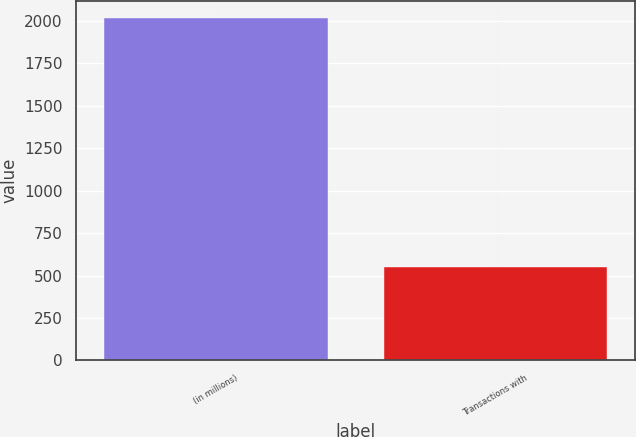Convert chart. <chart><loc_0><loc_0><loc_500><loc_500><bar_chart><fcel>(in millions)<fcel>Transactions with<nl><fcel>2016<fcel>552.9<nl></chart> 